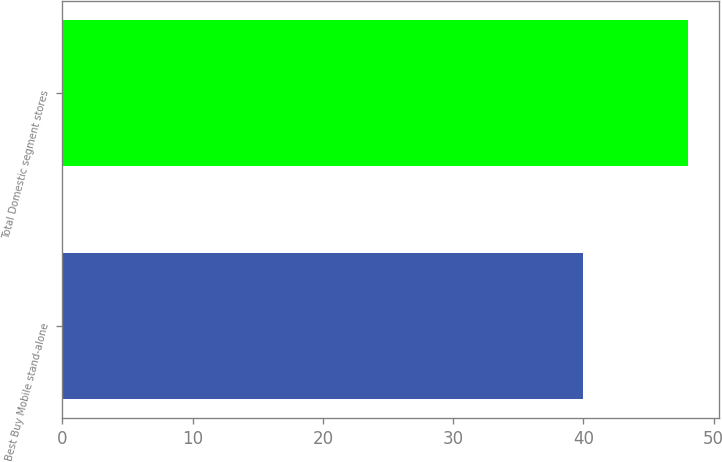Convert chart to OTSL. <chart><loc_0><loc_0><loc_500><loc_500><bar_chart><fcel>Best Buy Mobile stand-alone<fcel>Total Domestic segment stores<nl><fcel>40<fcel>48<nl></chart> 